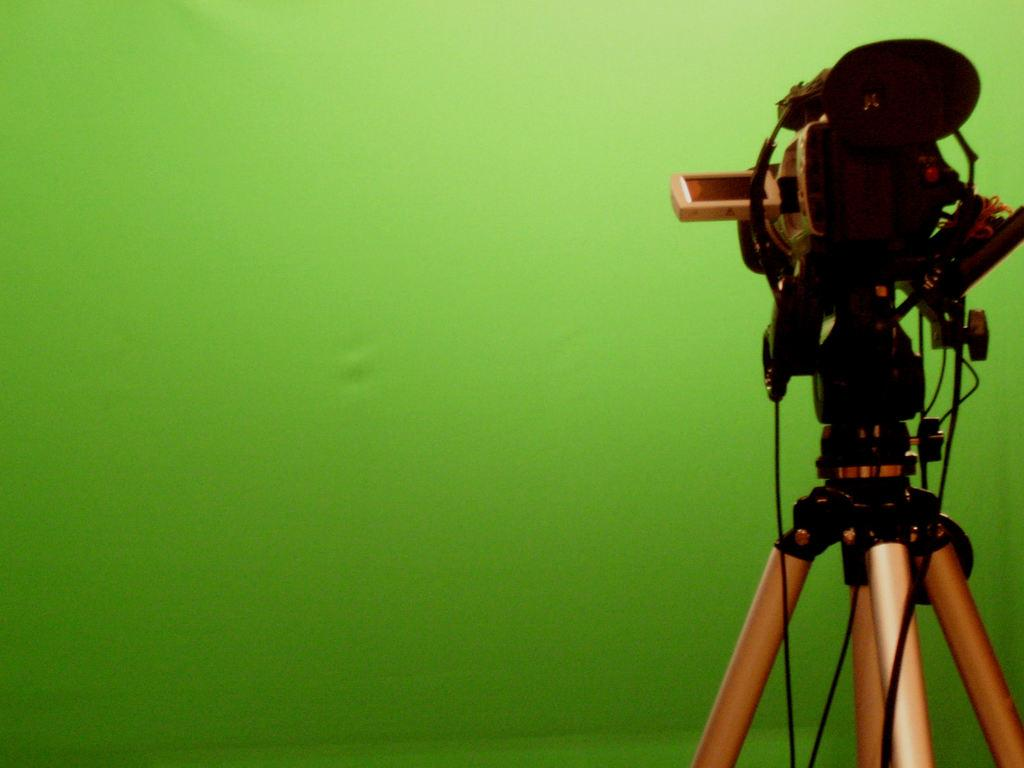What is the main object in the image? There is a camera with a stand in the image. What can be seen in the background of the image? There is a green cloth in the background of the image. What type of bait is being used to catch fish in the image? There is no mention of fish or bait in the image; it features a camera with a stand and a green cloth in the background. 